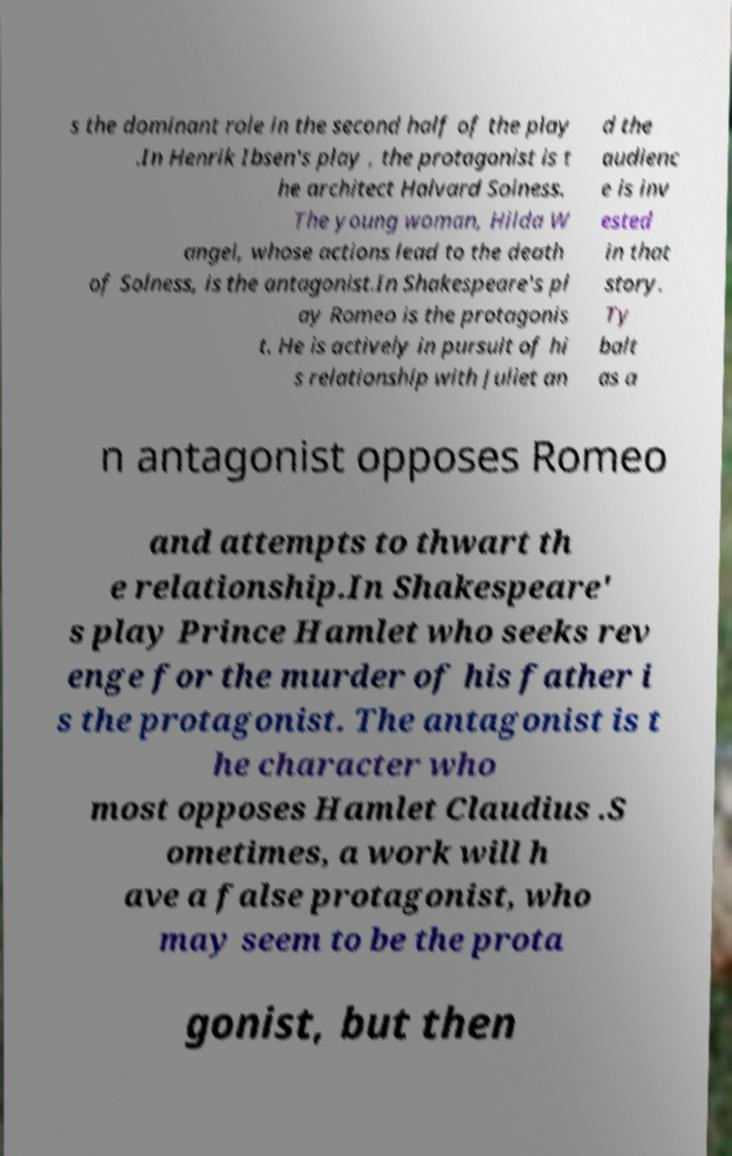For documentation purposes, I need the text within this image transcribed. Could you provide that? s the dominant role in the second half of the play .In Henrik Ibsen's play , the protagonist is t he architect Halvard Solness. The young woman, Hilda W angel, whose actions lead to the death of Solness, is the antagonist.In Shakespeare's pl ay Romeo is the protagonis t. He is actively in pursuit of hi s relationship with Juliet an d the audienc e is inv ested in that story. Ty balt as a n antagonist opposes Romeo and attempts to thwart th e relationship.In Shakespeare' s play Prince Hamlet who seeks rev enge for the murder of his father i s the protagonist. The antagonist is t he character who most opposes Hamlet Claudius .S ometimes, a work will h ave a false protagonist, who may seem to be the prota gonist, but then 